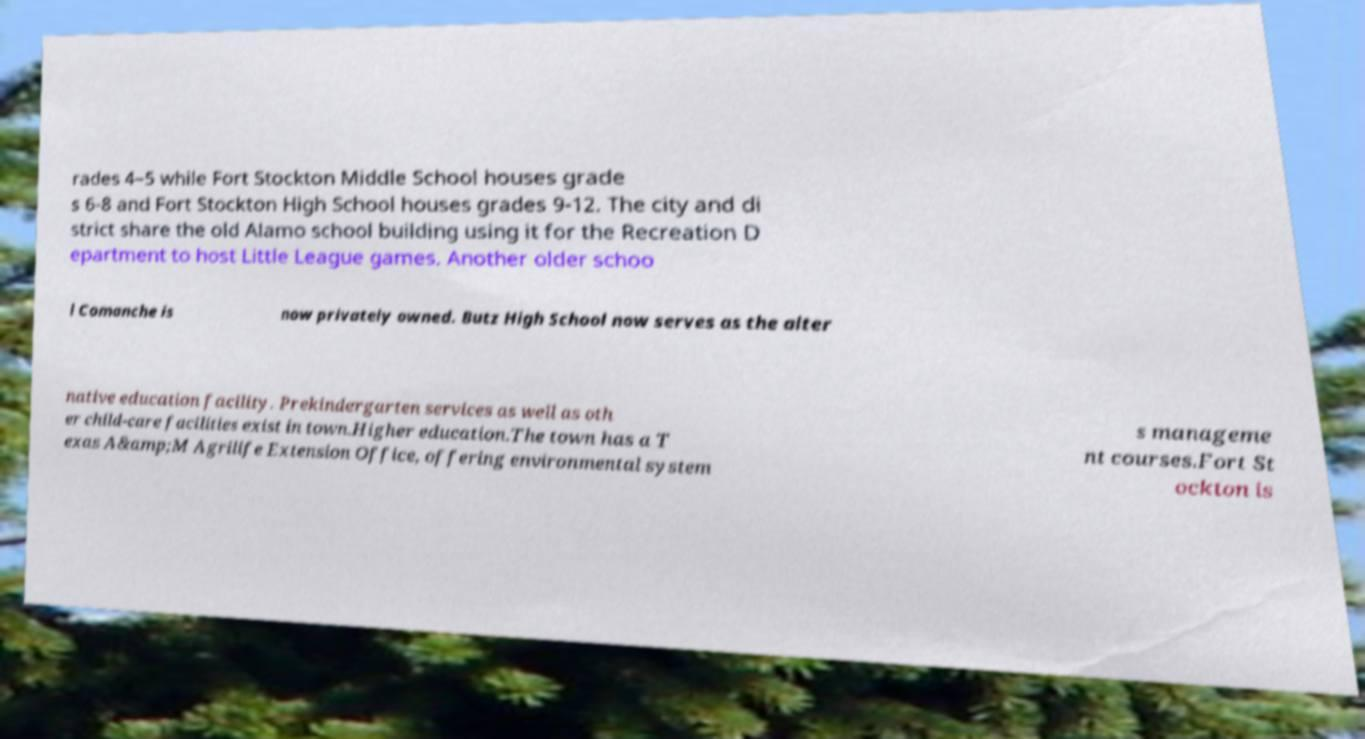I need the written content from this picture converted into text. Can you do that? rades 4–5 while Fort Stockton Middle School houses grade s 6-8 and Fort Stockton High School houses grades 9-12. The city and di strict share the old Alamo school building using it for the Recreation D epartment to host Little League games. Another older schoo l Comanche is now privately owned. Butz High School now serves as the alter native education facility. Prekindergarten services as well as oth er child-care facilities exist in town.Higher education.The town has a T exas A&amp;M Agrilife Extension Office, offering environmental system s manageme nt courses.Fort St ockton is 